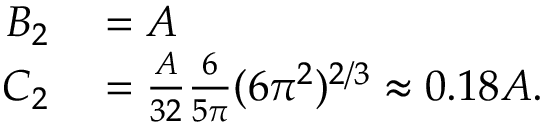<formula> <loc_0><loc_0><loc_500><loc_500>\begin{array} { r l } { B _ { 2 } } & = A } \\ { C _ { 2 } } & = \frac { A } { 3 2 } \frac { 6 } { 5 \pi } ( 6 \pi ^ { 2 } ) ^ { 2 / 3 } \approx 0 . 1 8 A . } \end{array}</formula> 